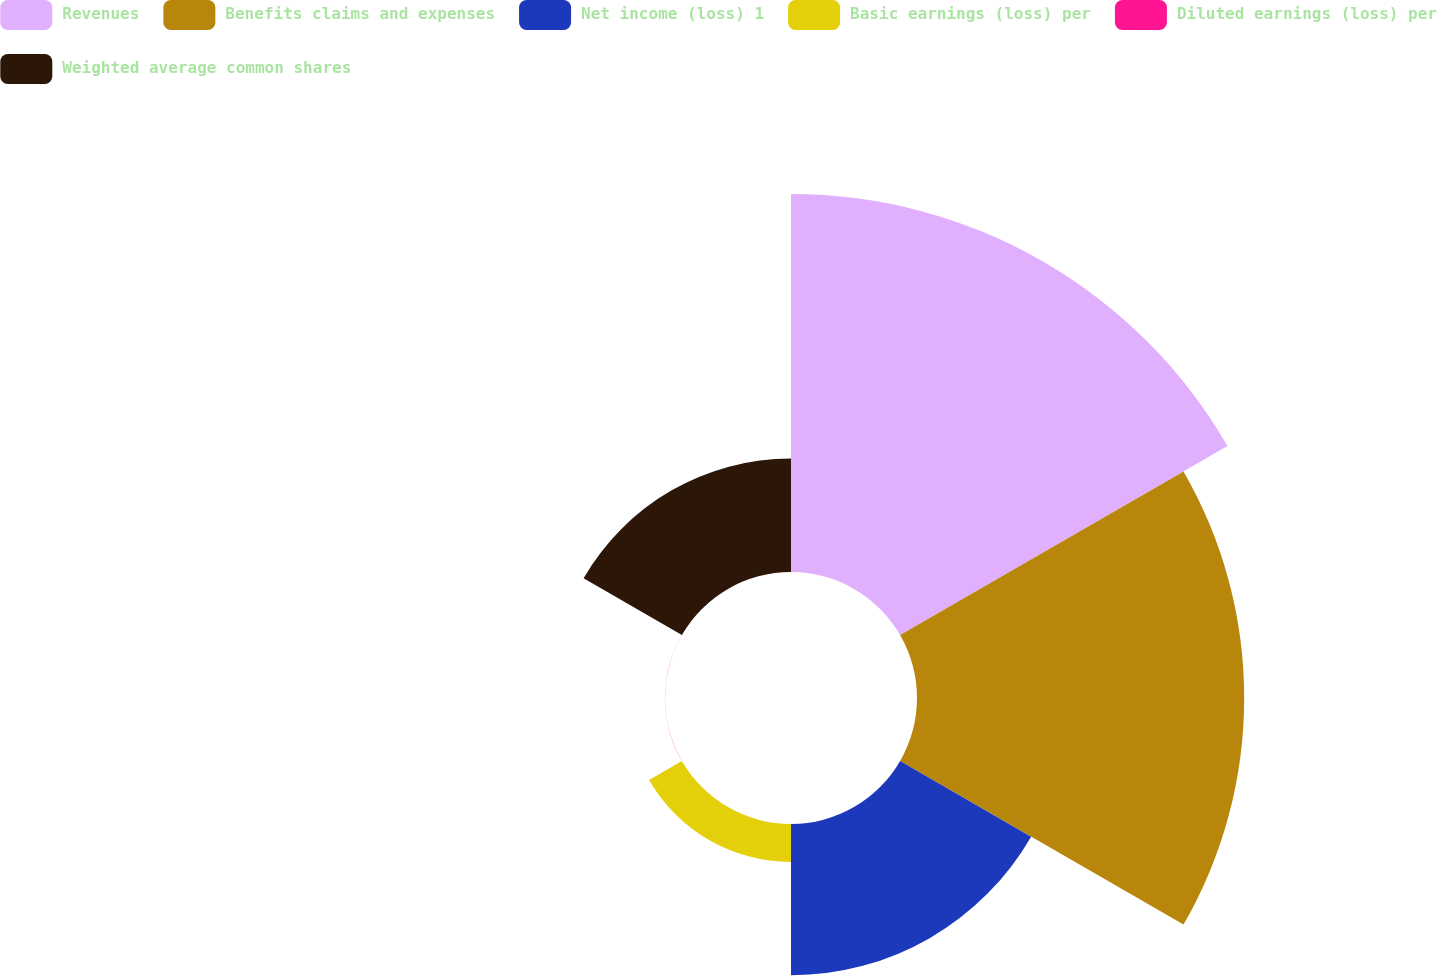<chart> <loc_0><loc_0><loc_500><loc_500><pie_chart><fcel>Revenues<fcel>Benefits claims and expenses<fcel>Net income (loss) 1<fcel>Basic earnings (loss) per<fcel>Diluted earnings (loss) per<fcel>Weighted average common shares<nl><fcel>37.5%<fcel>32.46%<fcel>15.01%<fcel>3.76%<fcel>0.01%<fcel>11.26%<nl></chart> 